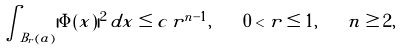<formula> <loc_0><loc_0><loc_500><loc_500>\int _ { B _ { r } ( a ) } | \Phi ( x ) | ^ { 2 } \, d x \leq c \, r ^ { n - 1 } , \quad 0 < r \leq 1 , \quad n \geq 2 ,</formula> 